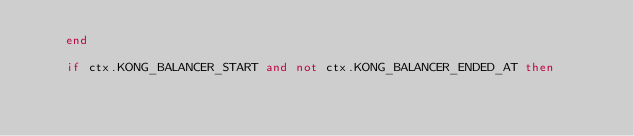Convert code to text. <code><loc_0><loc_0><loc_500><loc_500><_Lua_>    end

    if ctx.KONG_BALANCER_START and not ctx.KONG_BALANCER_ENDED_AT then</code> 